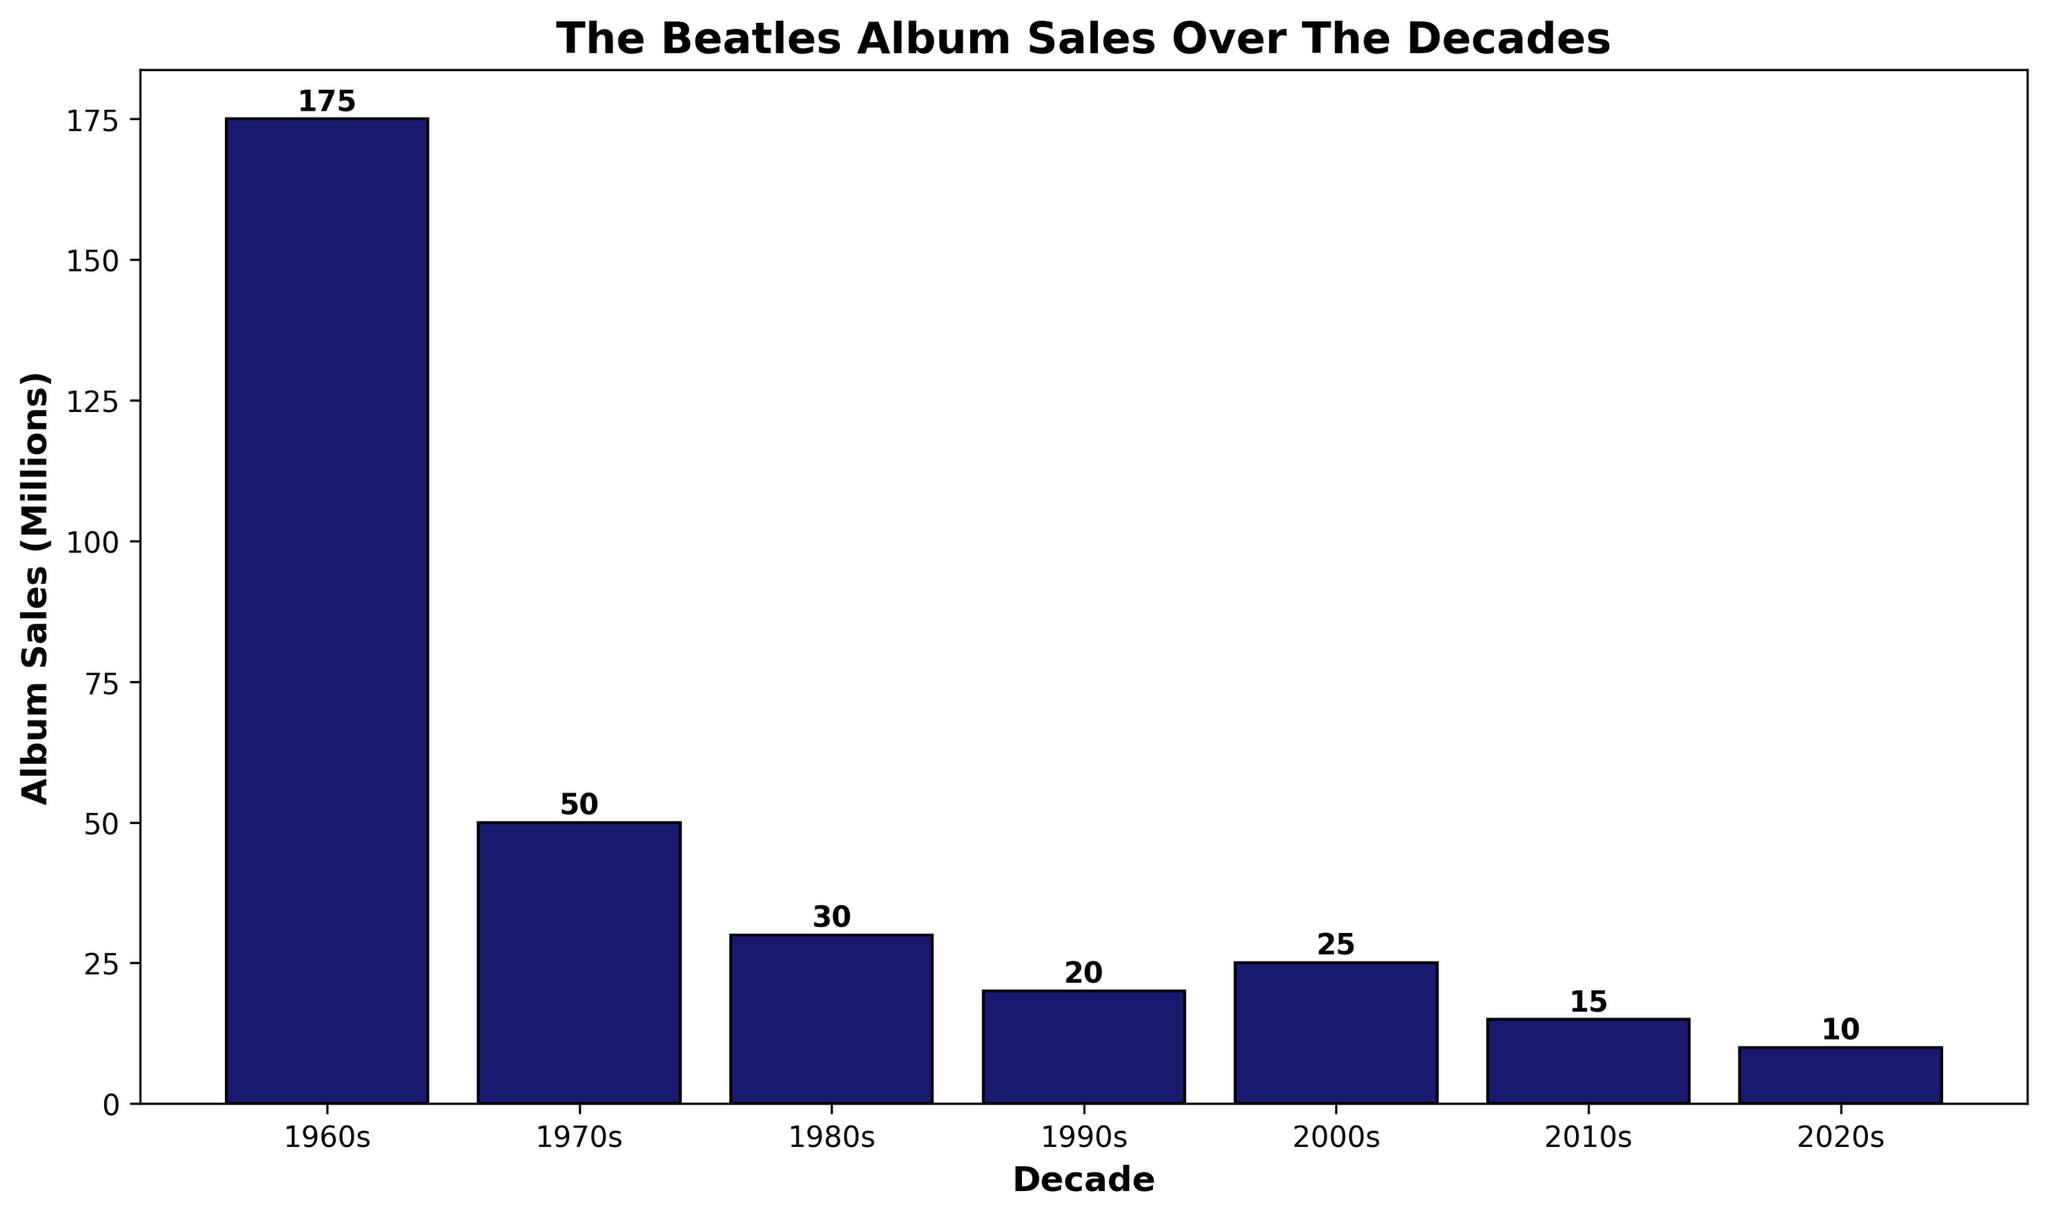Which decade had the highest album sales for The Beatles? The bar representing the 1960s is the tallest, indicating that The Beatles' album sales were highest in this decade.
Answer: 1960s What is the total album sales from the 1990s to the 2020s? Adding the sales from each decade: 1990s (20 million) + 2000s (25 million) + 2010s (15 million) + 2020s (10 million) = 70 million
Answer: 70 million How do the album sales of the 2000s compare to the 1970s? The bar height for the 1970s (50 million) is greater than that of the 2000s (25 million), meaning the sales in the 2000s are half of the 1970s.
Answer: Less, 25 million (2000s) vs 50 million (1970s) Which two consecutive decades showed the greatest decrease in album sales? The bars from the 1960s (175 million) to the 1970s (50 million) show the sharpest decline, which is a difference of 125 million.
Answer: 1960s to 1970s What was the average album sales per decade? Sum all album sales: 175 + 50 + 30 + 20 + 25 + 15 + 10 = 325; divide by the number of decades (7): 325 / 7 ≈ 46.43 million per decade
Answer: Approximately 46.43 million By how much did the album sales decrease from the 1960s to the 2010s? Subtract the sales of the 2010s (15 million) from the 1960s (175 million): 175 - 15 = 160 million
Answer: 160 million Compare the album sales of the 1980s and the 2020s. Which decade had higher sales and by how much? Subtract the sales of the 2020s (10 million) from the 1980s (30 million): 30 - 10 = 20 million. The 1980s had 20 million more in album sales.
Answer: 1980s, by 20 million What proportion of total album sales were made in the 1960s? The total sales are 325 million. The sales in the 1960s are 175 million. The proportion is 175/325 ≈ 0.538 or 53.8%.
Answer: 53.8% How does the visual height of the bar for the 2010s compare to the bar for the 2000s? The bar for the 2010s is shorter than the bar for the 2000s, indicating fewer sales in the 2010s (15 million) compared to the 2000s (25 million).
Answer: Shorter When did album sales drop below 50 million for the first time? The bar height drops below 50 million starting from the 1980s (30 million).
Answer: 1980s 